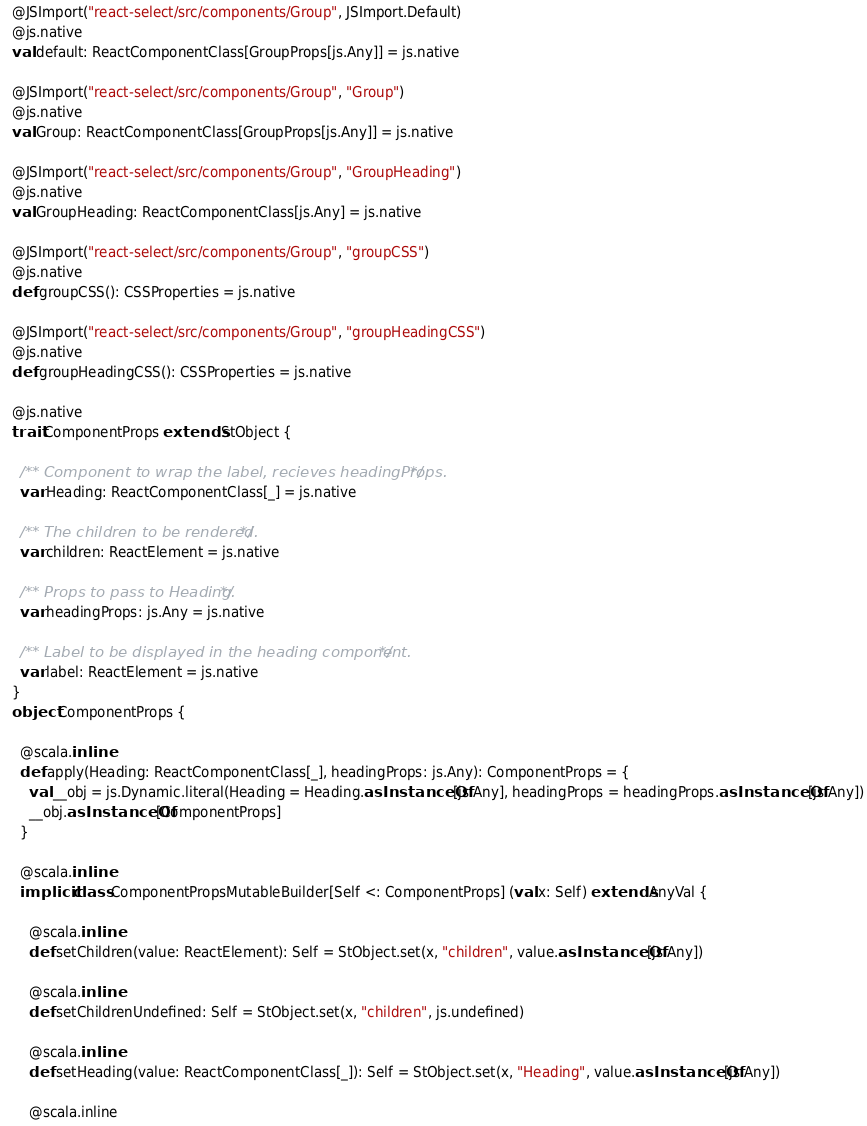Convert code to text. <code><loc_0><loc_0><loc_500><loc_500><_Scala_>  @JSImport("react-select/src/components/Group", JSImport.Default)
  @js.native
  val default: ReactComponentClass[GroupProps[js.Any]] = js.native
  
  @JSImport("react-select/src/components/Group", "Group")
  @js.native
  val Group: ReactComponentClass[GroupProps[js.Any]] = js.native
  
  @JSImport("react-select/src/components/Group", "GroupHeading")
  @js.native
  val GroupHeading: ReactComponentClass[js.Any] = js.native
  
  @JSImport("react-select/src/components/Group", "groupCSS")
  @js.native
  def groupCSS(): CSSProperties = js.native
  
  @JSImport("react-select/src/components/Group", "groupHeadingCSS")
  @js.native
  def groupHeadingCSS(): CSSProperties = js.native
  
  @js.native
  trait ComponentProps extends StObject {
    
    /** Component to wrap the label, recieves headingProps. */
    var Heading: ReactComponentClass[_] = js.native
    
    /** The children to be rendered. */
    var children: ReactElement = js.native
    
    /** Props to pass to Heading. */
    var headingProps: js.Any = js.native
    
    /** Label to be displayed in the heading component. */
    var label: ReactElement = js.native
  }
  object ComponentProps {
    
    @scala.inline
    def apply(Heading: ReactComponentClass[_], headingProps: js.Any): ComponentProps = {
      val __obj = js.Dynamic.literal(Heading = Heading.asInstanceOf[js.Any], headingProps = headingProps.asInstanceOf[js.Any])
      __obj.asInstanceOf[ComponentProps]
    }
    
    @scala.inline
    implicit class ComponentPropsMutableBuilder[Self <: ComponentProps] (val x: Self) extends AnyVal {
      
      @scala.inline
      def setChildren(value: ReactElement): Self = StObject.set(x, "children", value.asInstanceOf[js.Any])
      
      @scala.inline
      def setChildrenUndefined: Self = StObject.set(x, "children", js.undefined)
      
      @scala.inline
      def setHeading(value: ReactComponentClass[_]): Self = StObject.set(x, "Heading", value.asInstanceOf[js.Any])
      
      @scala.inline</code> 